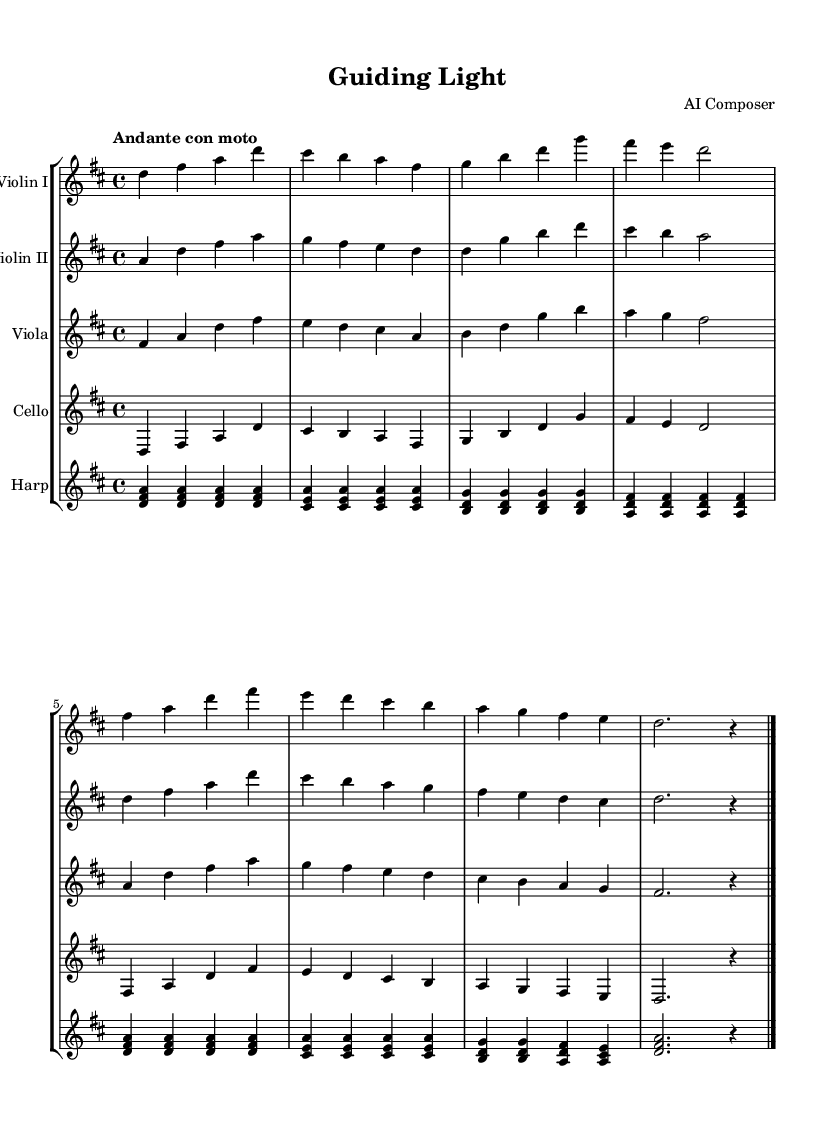What is the key signature of this music? The key signature can be identified at the beginning of the score; it shows two sharps, which indicates it is in the key of D major.
Answer: D major What is the time signature of this music? The time signature is found at the beginning of the score, represented as a fraction; it shows 4 over 4, meaning there are four beats per measure with a quarter note getting one beat.
Answer: 4/4 What is the tempo marking for this piece? The tempo is indicated at the beginning under the global settings; it is marked as "Andante con moto," which means moderately slow with some movement.
Answer: Andante con moto How many measures are there in the first violin part? By counting the number of distinct groupings separated by vertical lines (bars) in the violin I part, there are eight measures total.
Answer: 8 Which instruments are featured in this symphonic composition? The instruments can be identified by their respective staff names above the music; they include Violin I, Violin II, Viola, Cello, and Harp.
Answer: Violin I, Violin II, Viola, Cello, Harp In which section of the score does the harp play its part? The harp part is notated after the Violin II and before the layout section, with its own staff indicating where its notes are written; it is the last instrument listed.
Answer: Last What dynamic level is indicated at the beginning of the piece? The dynamic level is not explicitly mentioned in the provided code or music notation, as it typically reflects the composer’s intent; therefore, it is likely not specified in this segment.
Answer: Not specified 